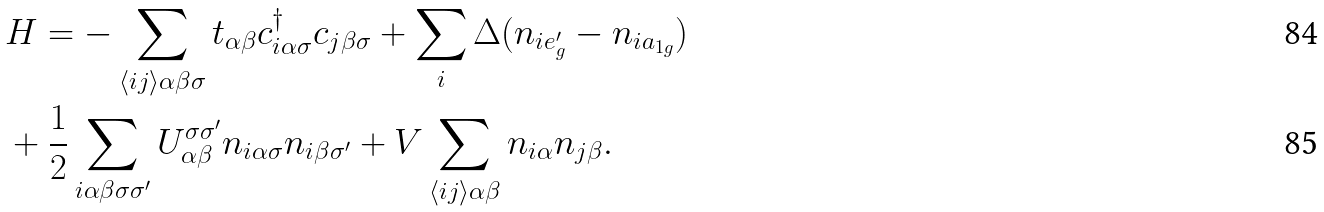<formula> <loc_0><loc_0><loc_500><loc_500>& H = - \sum _ { \langle i j \rangle \alpha \beta \sigma } t _ { \alpha \beta } c ^ { \dagger } _ { i \alpha \sigma } c _ { j \beta \sigma } + \sum _ { i } \Delta ( n _ { i e _ { g } ^ { \prime } } - n _ { i a _ { 1 g } } ) \\ & + \frac { 1 } { 2 } \sum _ { i \alpha \beta \sigma \sigma ^ { \prime } } U _ { \alpha \beta } ^ { \sigma \sigma ^ { \prime } } n _ { i \alpha \sigma } n _ { i \beta \sigma ^ { \prime } } + V \sum _ { \langle i j \rangle \alpha \beta } n _ { i \alpha } n _ { j \beta } .</formula> 